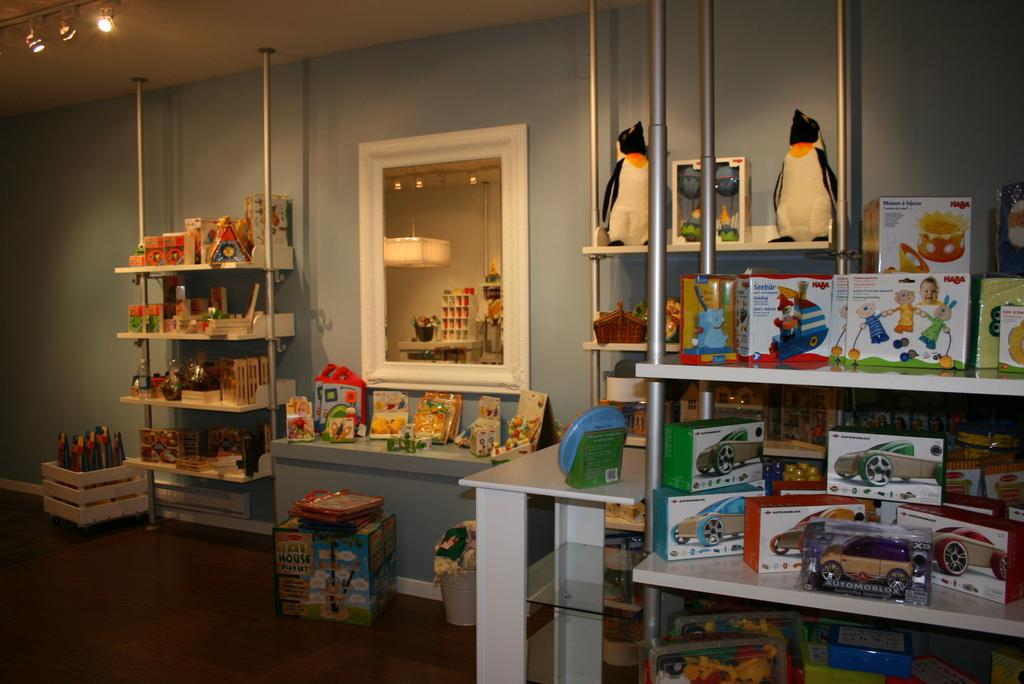<image>
Render a clear and concise summary of the photo. Some toys are in the shelf and some Haba toys are in the upper rack. 